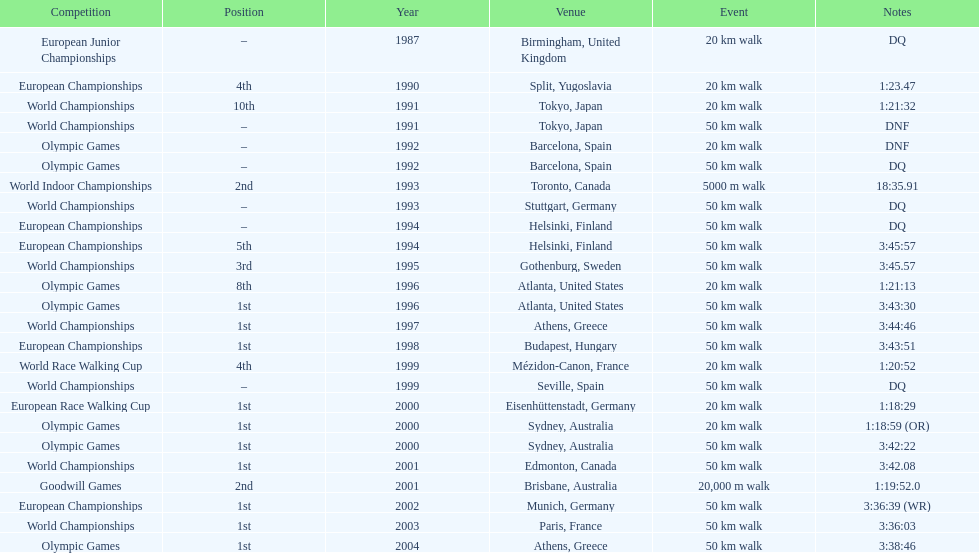How many times was first place listed as the position? 10. 